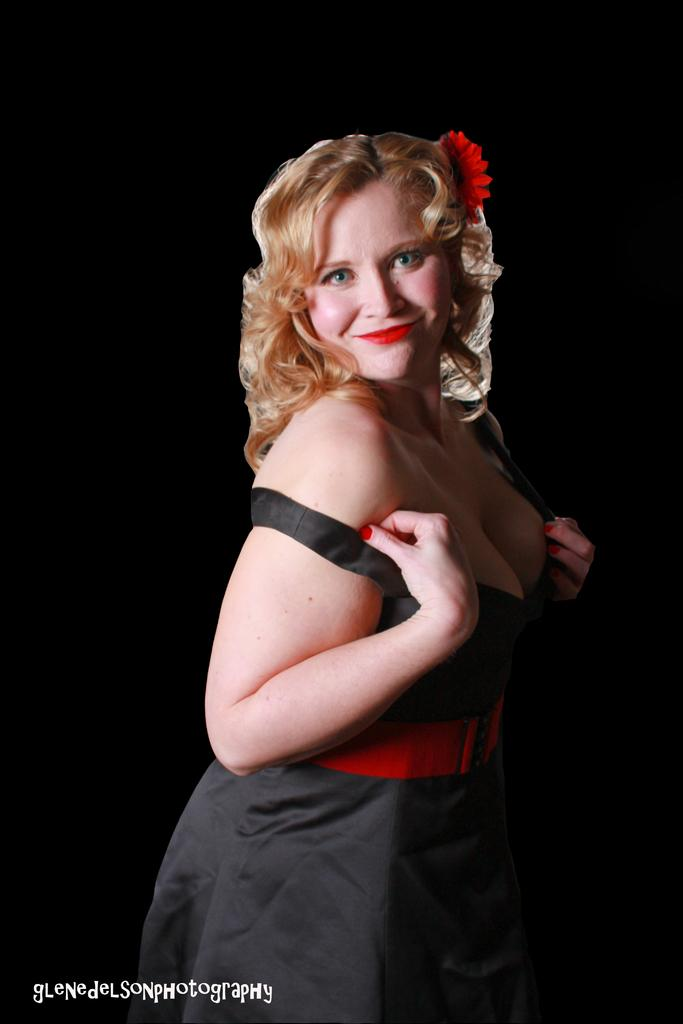What is the main subject of the image? The main subject of the image is a woman. Can you describe the woman's position in the image? The woman is standing in the image. What type of lizards can be seen crawling on the woman's shoulder in the image? There are no lizards present in the image. What type of vegetable is the woman holding in the image? The image does not show the woman holding any vegetable, such as cabbage. 